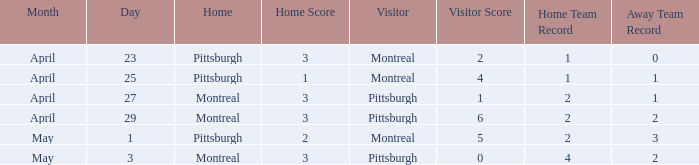What was the score on May 3? 3 - 0. 